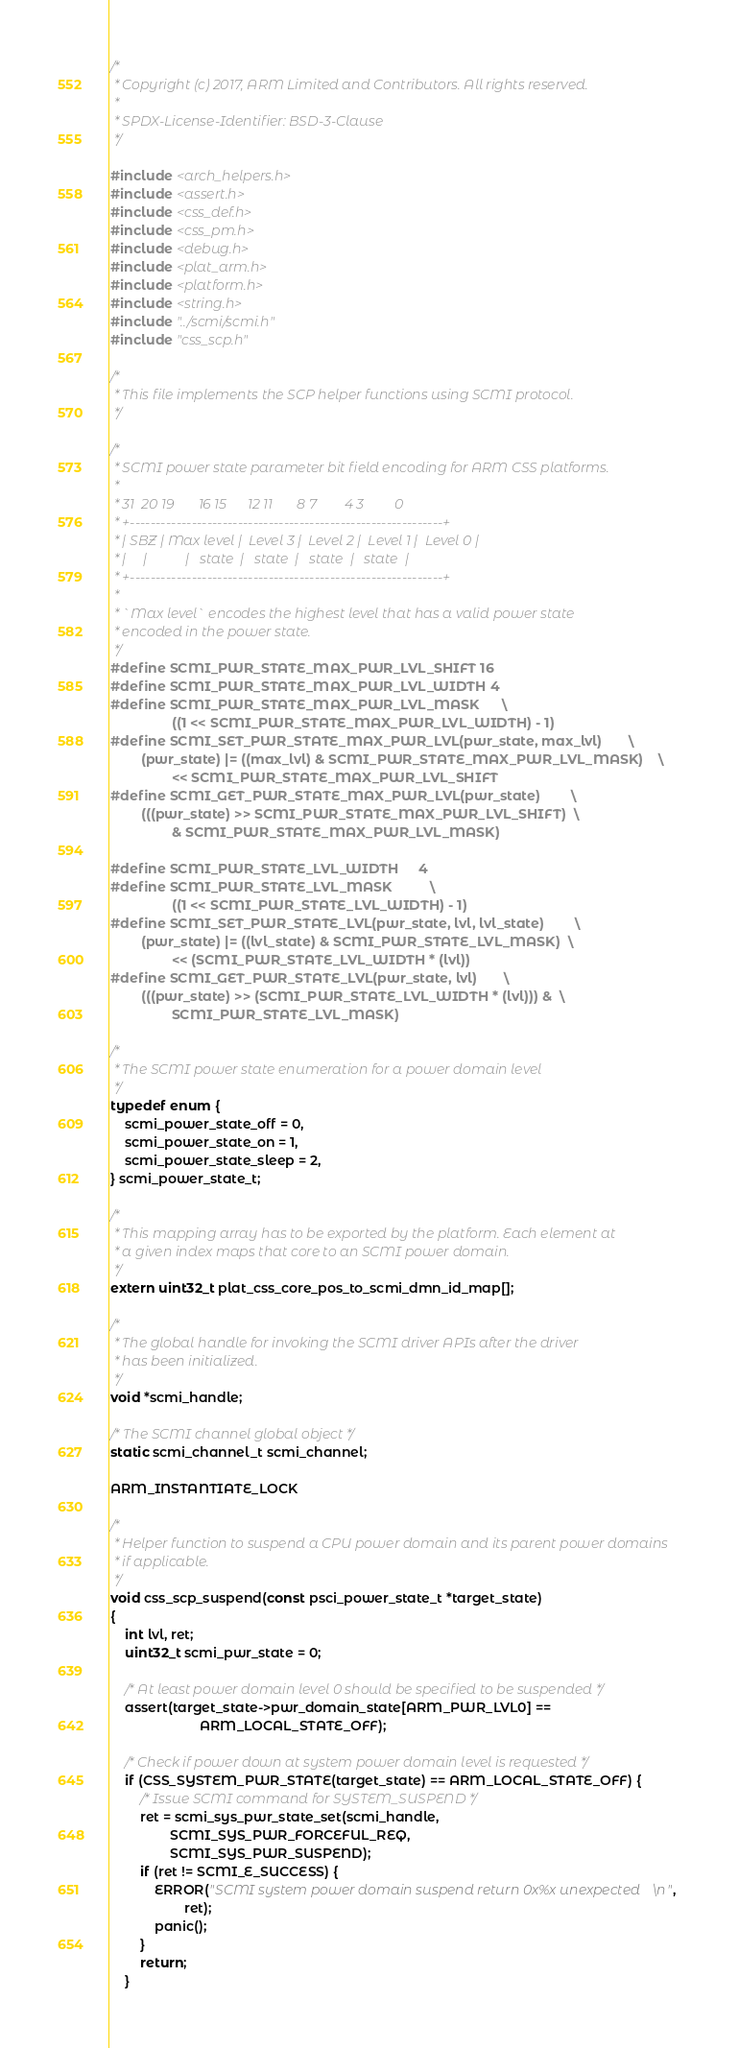<code> <loc_0><loc_0><loc_500><loc_500><_C_>/*
 * Copyright (c) 2017, ARM Limited and Contributors. All rights reserved.
 *
 * SPDX-License-Identifier: BSD-3-Clause
 */

#include <arch_helpers.h>
#include <assert.h>
#include <css_def.h>
#include <css_pm.h>
#include <debug.h>
#include <plat_arm.h>
#include <platform.h>
#include <string.h>
#include "../scmi/scmi.h"
#include "css_scp.h"

/*
 * This file implements the SCP helper functions using SCMI protocol.
 */

/*
 * SCMI power state parameter bit field encoding for ARM CSS platforms.
 *
 * 31  20 19       16 15      12 11       8 7        4 3         0
 * +-------------------------------------------------------------+
 * | SBZ | Max level |  Level 3 |  Level 2 |  Level 1 |  Level 0 |
 * |     |           |   state  |   state  |   state  |   state  |
 * +-------------------------------------------------------------+
 *
 * `Max level` encodes the highest level that has a valid power state
 * encoded in the power state.
 */
#define SCMI_PWR_STATE_MAX_PWR_LVL_SHIFT	16
#define SCMI_PWR_STATE_MAX_PWR_LVL_WIDTH	4
#define SCMI_PWR_STATE_MAX_PWR_LVL_MASK		\
				((1 << SCMI_PWR_STATE_MAX_PWR_LVL_WIDTH) - 1)
#define SCMI_SET_PWR_STATE_MAX_PWR_LVL(pwr_state, max_lvl)		\
		(pwr_state) |= ((max_lvl) & SCMI_PWR_STATE_MAX_PWR_LVL_MASK)	\
				<< SCMI_PWR_STATE_MAX_PWR_LVL_SHIFT
#define SCMI_GET_PWR_STATE_MAX_PWR_LVL(pwr_state)		\
		(((pwr_state) >> SCMI_PWR_STATE_MAX_PWR_LVL_SHIFT)	\
				& SCMI_PWR_STATE_MAX_PWR_LVL_MASK)

#define SCMI_PWR_STATE_LVL_WIDTH		4
#define SCMI_PWR_STATE_LVL_MASK			\
				((1 << SCMI_PWR_STATE_LVL_WIDTH) - 1)
#define SCMI_SET_PWR_STATE_LVL(pwr_state, lvl, lvl_state)		\
		(pwr_state) |= ((lvl_state) & SCMI_PWR_STATE_LVL_MASK)	\
				<< (SCMI_PWR_STATE_LVL_WIDTH * (lvl))
#define SCMI_GET_PWR_STATE_LVL(pwr_state, lvl)		\
		(((pwr_state) >> (SCMI_PWR_STATE_LVL_WIDTH * (lvl))) &	\
				SCMI_PWR_STATE_LVL_MASK)

/*
 * The SCMI power state enumeration for a power domain level
 */
typedef enum {
	scmi_power_state_off = 0,
	scmi_power_state_on = 1,
	scmi_power_state_sleep = 2,
} scmi_power_state_t;

/*
 * This mapping array has to be exported by the platform. Each element at
 * a given index maps that core to an SCMI power domain.
 */
extern uint32_t plat_css_core_pos_to_scmi_dmn_id_map[];

/*
 * The global handle for invoking the SCMI driver APIs after the driver
 * has been initialized.
 */
void *scmi_handle;

/* The SCMI channel global object */
static scmi_channel_t scmi_channel;

ARM_INSTANTIATE_LOCK

/*
 * Helper function to suspend a CPU power domain and its parent power domains
 * if applicable.
 */
void css_scp_suspend(const psci_power_state_t *target_state)
{
	int lvl, ret;
	uint32_t scmi_pwr_state = 0;

	/* At least power domain level 0 should be specified to be suspended */
	assert(target_state->pwr_domain_state[ARM_PWR_LVL0] ==
						ARM_LOCAL_STATE_OFF);

	/* Check if power down at system power domain level is requested */
	if (CSS_SYSTEM_PWR_STATE(target_state) == ARM_LOCAL_STATE_OFF) {
		/* Issue SCMI command for SYSTEM_SUSPEND */
		ret = scmi_sys_pwr_state_set(scmi_handle,
				SCMI_SYS_PWR_FORCEFUL_REQ,
				SCMI_SYS_PWR_SUSPEND);
		if (ret != SCMI_E_SUCCESS) {
			ERROR("SCMI system power domain suspend return 0x%x unexpected\n",
					ret);
			panic();
		}
		return;
	}
</code> 